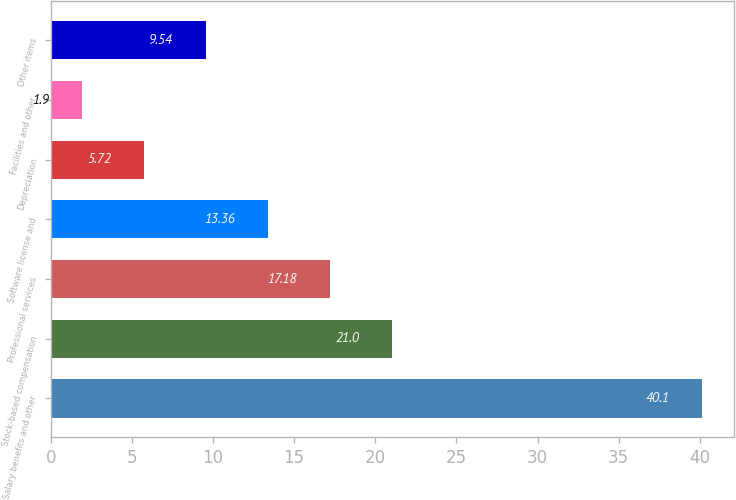Convert chart. <chart><loc_0><loc_0><loc_500><loc_500><bar_chart><fcel>Salary benefits and other<fcel>Stock-based compensation<fcel>Professional services<fcel>Software license and<fcel>Depreciation<fcel>Facilities and other<fcel>Other items<nl><fcel>40.1<fcel>21<fcel>17.18<fcel>13.36<fcel>5.72<fcel>1.9<fcel>9.54<nl></chart> 